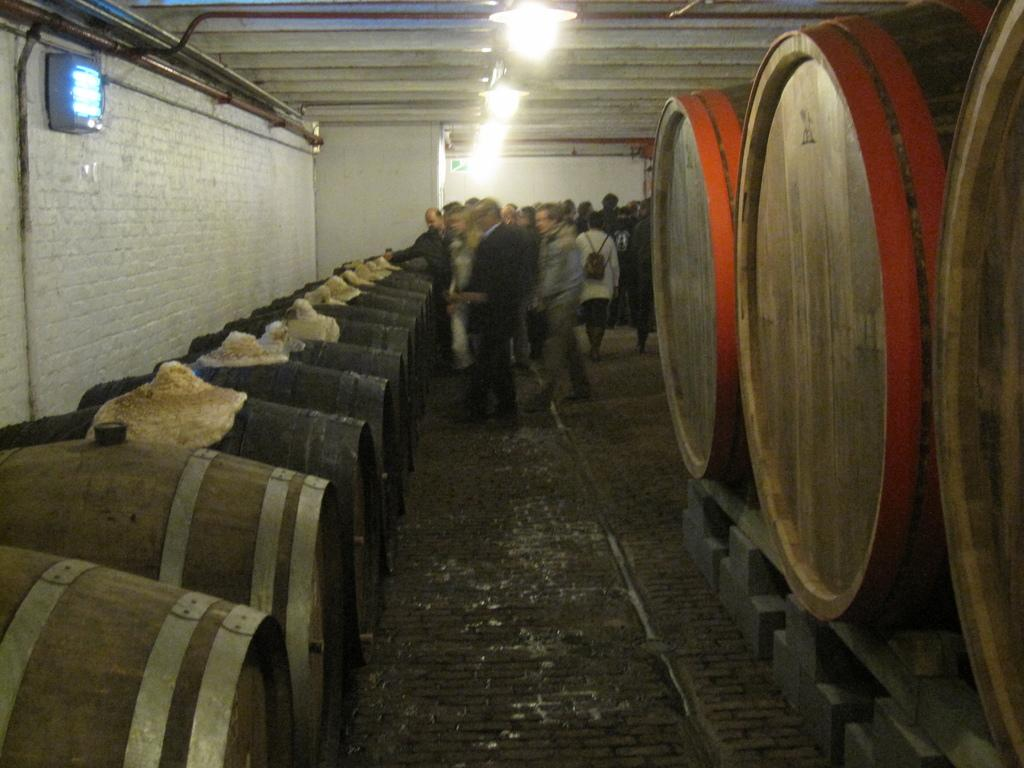What is the color of the wall in the image? The wall in the image is white. What can be seen illuminating the scene in the image? There are lights in the image. Who or what is present in the image? There are people and drums in the image. What type of jelly is being used as a drumstick in the image? There is no jelly or drumstick present in the image; it features people and drums. What type of juice is being served to the people in the image? There is no juice or indication of a beverage being served in the image. 